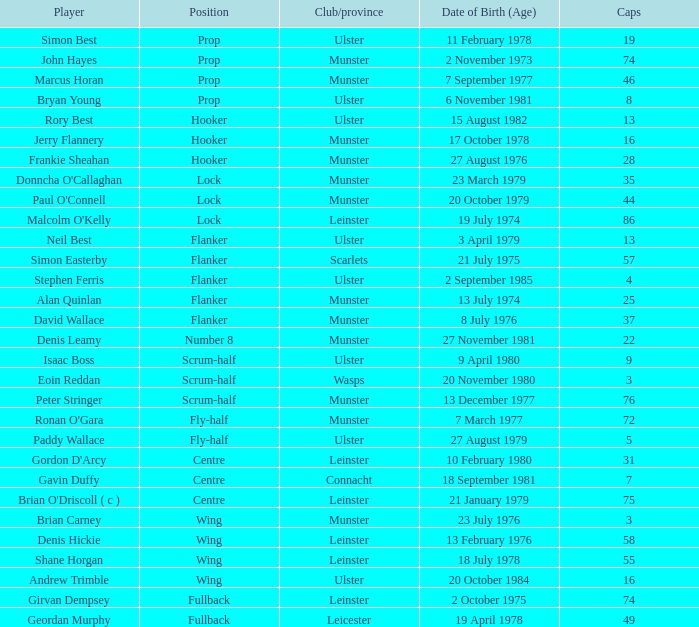What is the club or province of Girvan Dempsey, who has 74 caps? Leinster. 